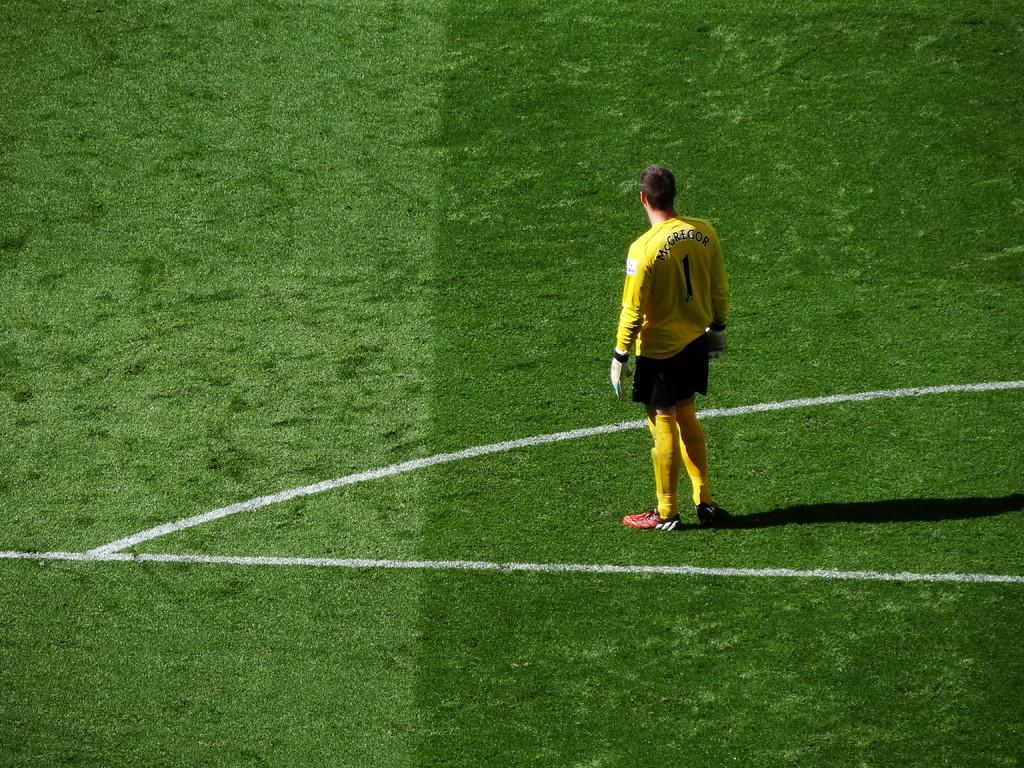What is present in the image? There is a person in the image. What is the person doing in the image? The person is standing on the ground. What is the person wearing in the image? The person is wearing a yellow dress. What word is written on the person's dress in the image? There is no word written on the person's dress in the image; it is simply a yellow dress. 